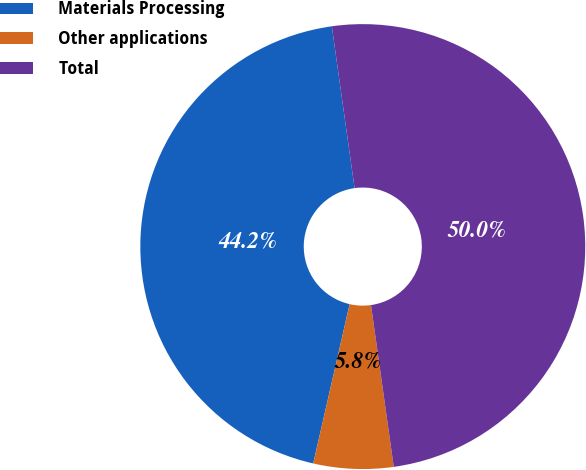<chart> <loc_0><loc_0><loc_500><loc_500><pie_chart><fcel>Materials Processing<fcel>Other applications<fcel>Total<nl><fcel>44.2%<fcel>5.8%<fcel>50.0%<nl></chart> 